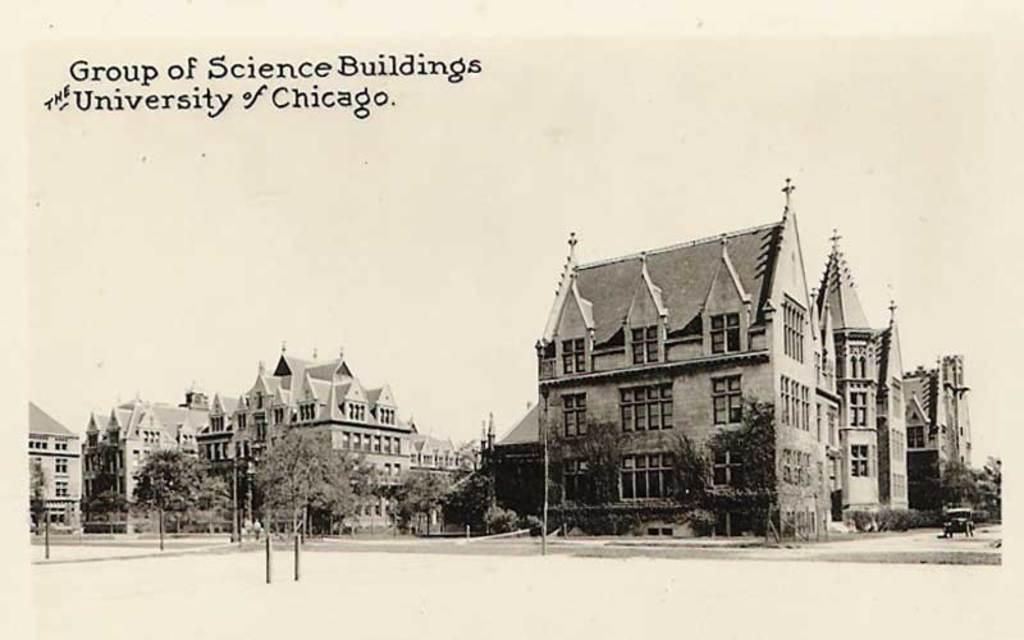What is the color scheme of the image? The image is black and white. What can be seen in the image besides the color scheme? There are many buildings, trees, and vehicles on the road in the image. Where are the trees located in the image? The trees are in the image, but their specific location is not mentioned in the facts. What is visible at the top of the image? There is text visible at the top of the image. What type of fork can be seen in the image? There is no fork present in the image. How many eyes can be seen on the trees in the image? Trees do not have eyes, so this question cannot be answered based on the facts provided. 